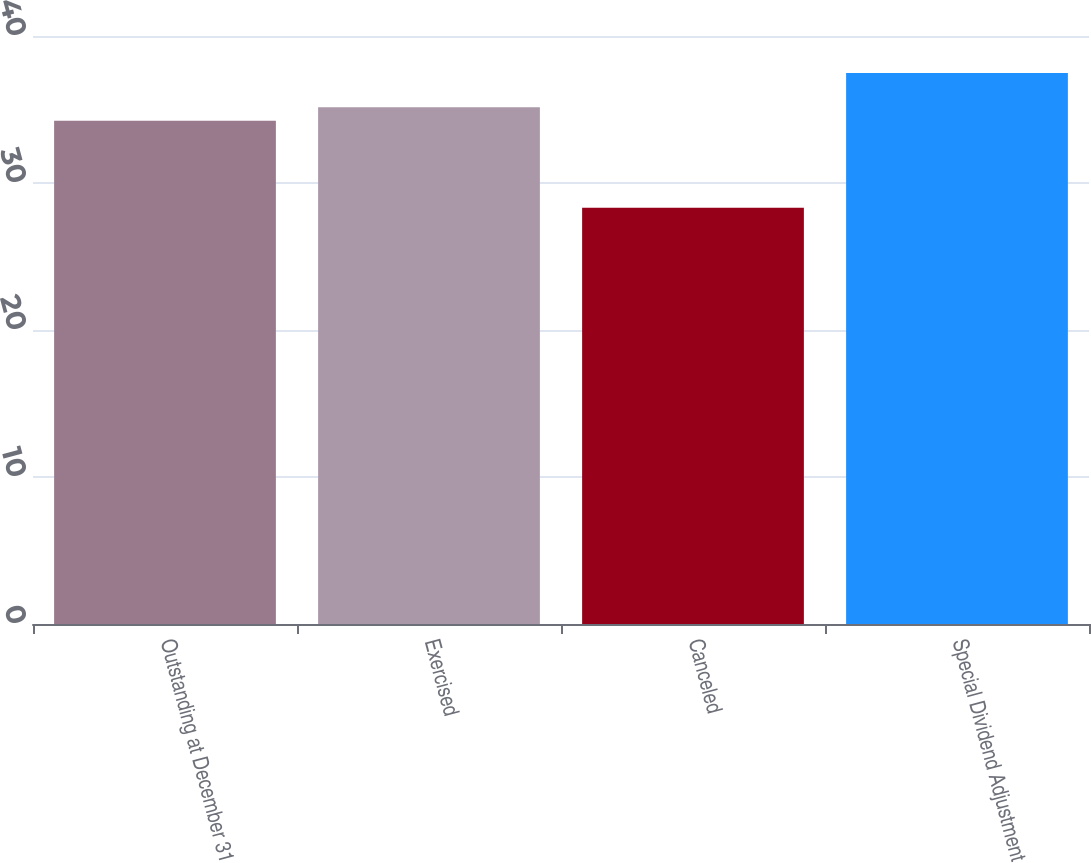Convert chart. <chart><loc_0><loc_0><loc_500><loc_500><bar_chart><fcel>Outstanding at December 31<fcel>Exercised<fcel>Canceled<fcel>Special Dividend Adjustment<nl><fcel>34.23<fcel>35.16<fcel>28.31<fcel>37.49<nl></chart> 